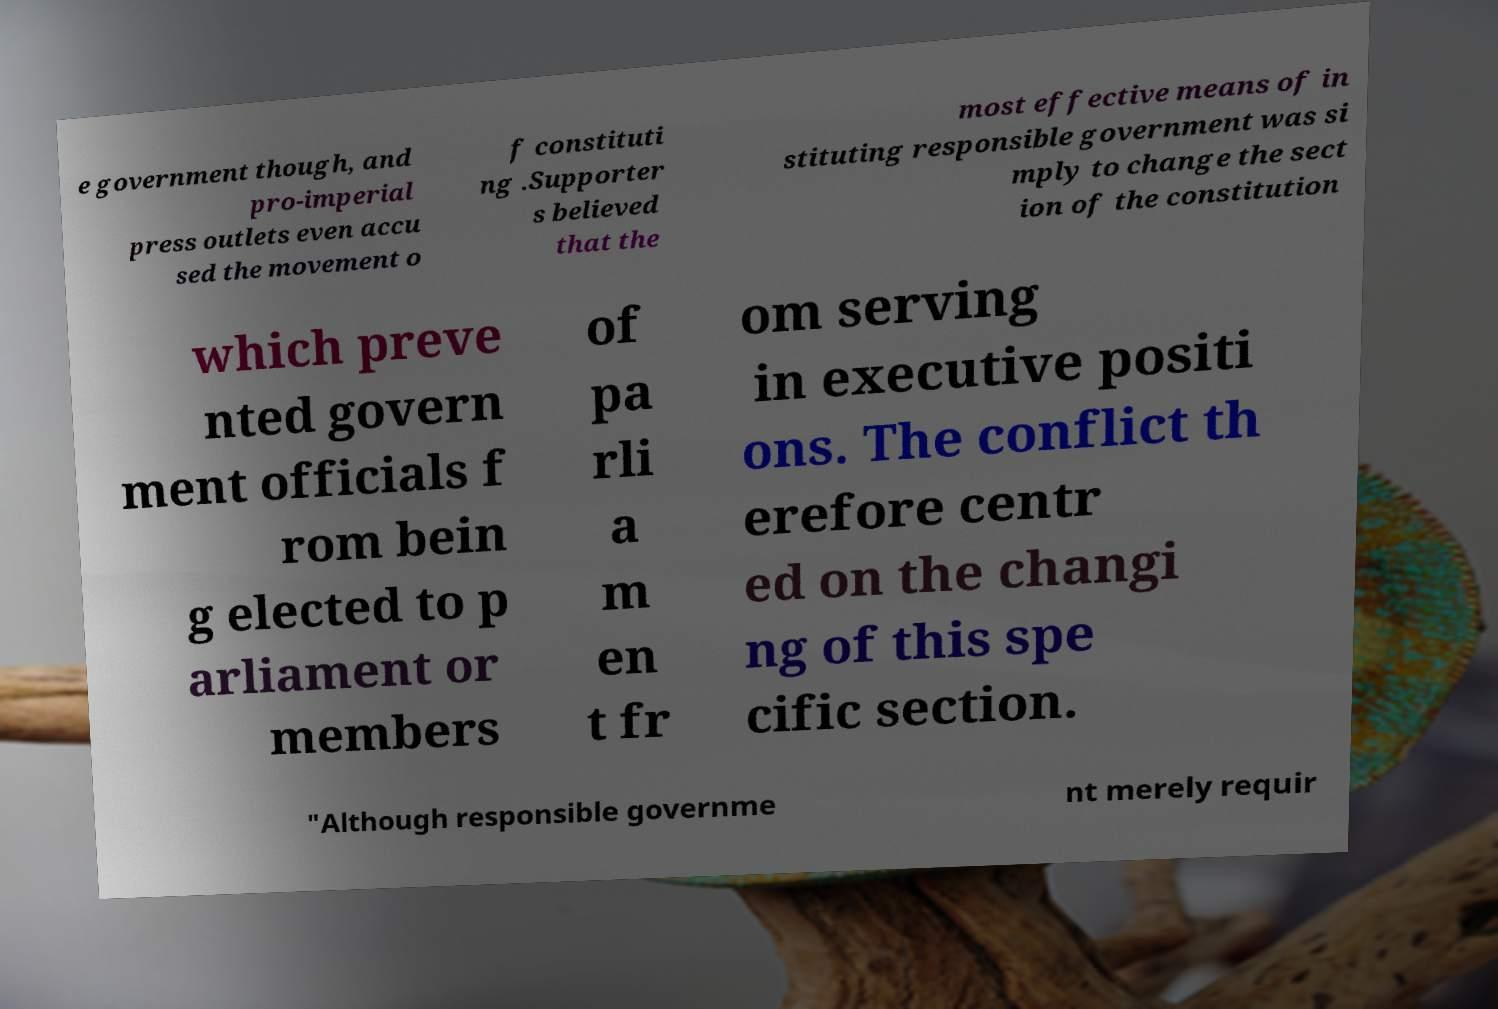Could you extract and type out the text from this image? e government though, and pro-imperial press outlets even accu sed the movement o f constituti ng .Supporter s believed that the most effective means of in stituting responsible government was si mply to change the sect ion of the constitution which preve nted govern ment officials f rom bein g elected to p arliament or members of pa rli a m en t fr om serving in executive positi ons. The conflict th erefore centr ed on the changi ng of this spe cific section. "Although responsible governme nt merely requir 